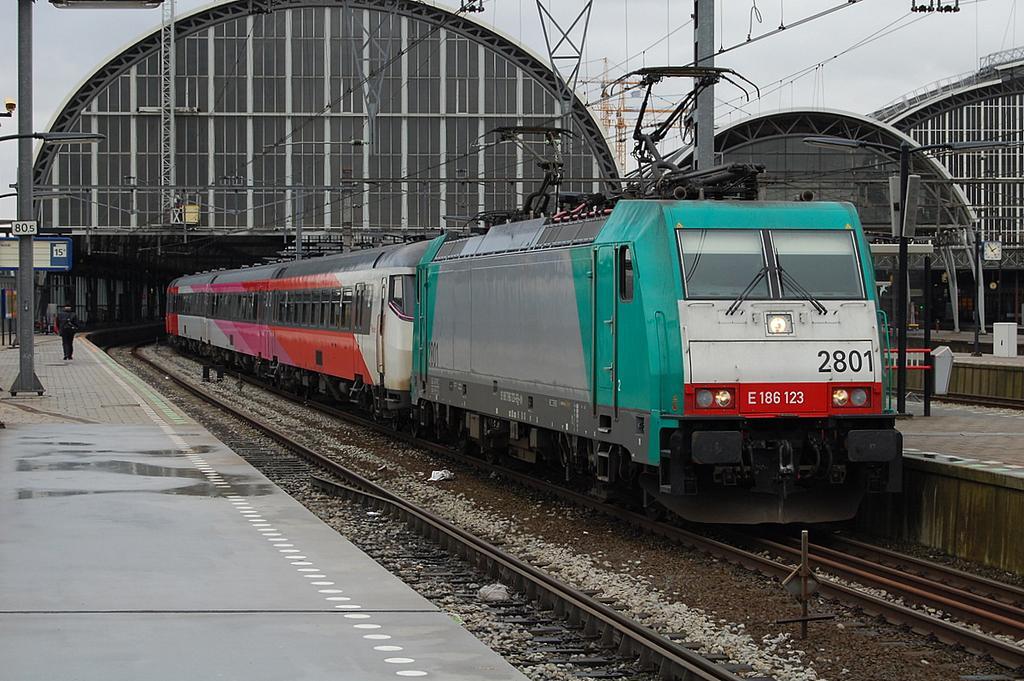Could you give a brief overview of what you see in this image? This image is taken in a railway station. In this image we can see the train on the track. We can also see the stones, platform, poles, wires and also the light pole. On the left we can see a person. In the background we can see the cranes, some rods and also the sky. 